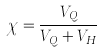<formula> <loc_0><loc_0><loc_500><loc_500>\chi = \frac { V _ { Q } } { V _ { Q } + V _ { H } }</formula> 